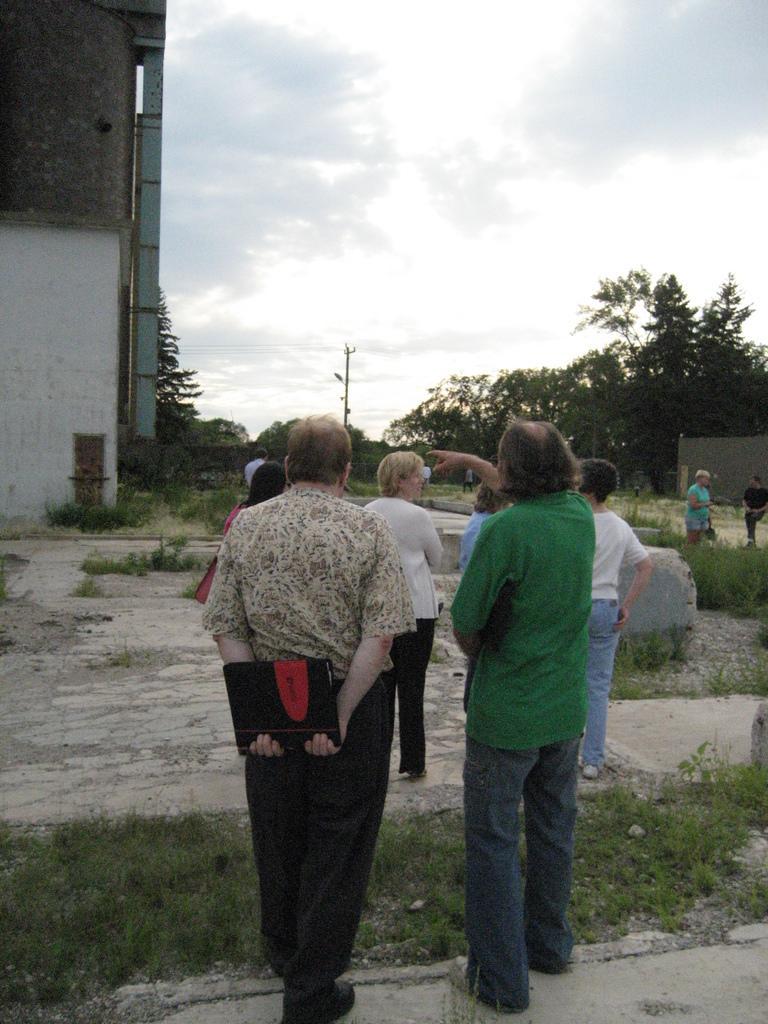Describe this image in one or two sentences. In this image there are some persons who are standing, at the bottom there is grass and sand in the background there are some trees buildings at the top of the image there is sky. 